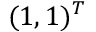<formula> <loc_0><loc_0><loc_500><loc_500>( 1 , 1 ) ^ { T }</formula> 